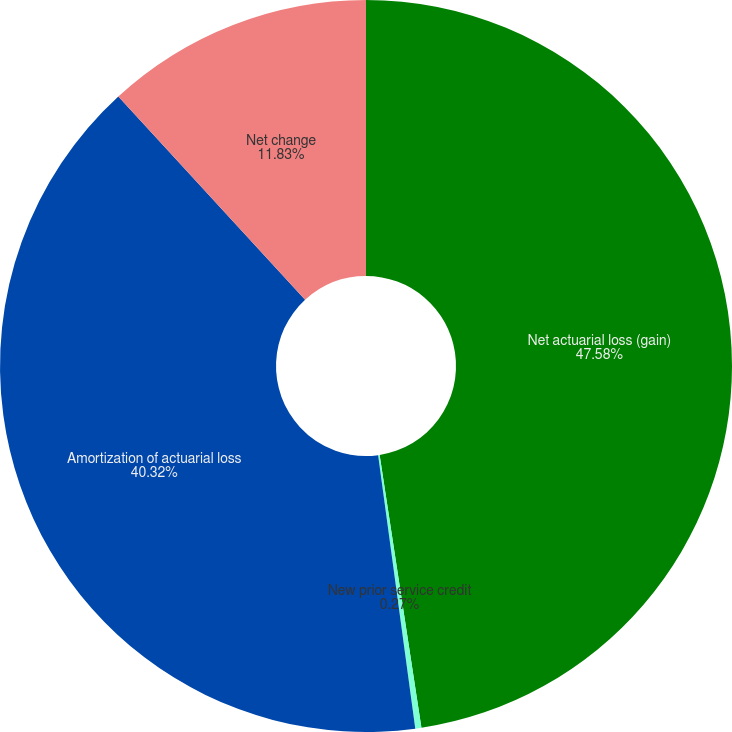Convert chart. <chart><loc_0><loc_0><loc_500><loc_500><pie_chart><fcel>Net actuarial loss (gain)<fcel>New prior service credit<fcel>Amortization of actuarial loss<fcel>Net change<nl><fcel>47.58%<fcel>0.27%<fcel>40.32%<fcel>11.83%<nl></chart> 